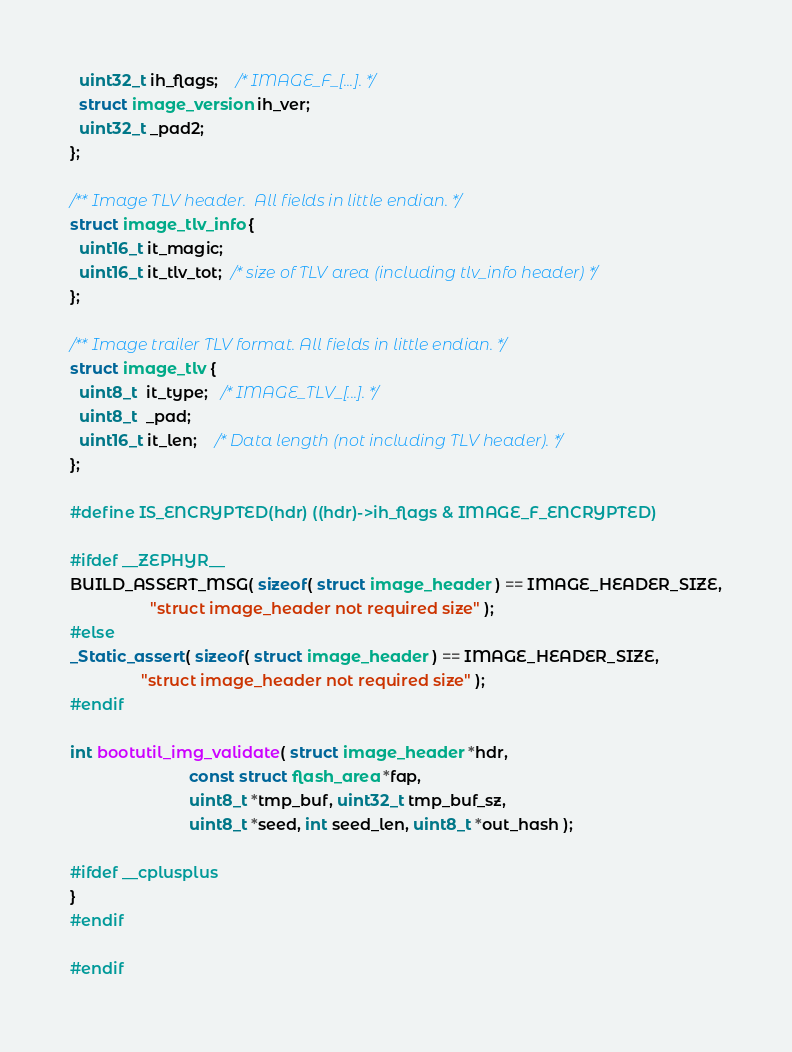Convert code to text. <code><loc_0><loc_0><loc_500><loc_500><_C_>  uint32_t ih_flags;    /* IMAGE_F_[...]. */
  struct image_version ih_ver;
  uint32_t _pad2;
};

/** Image TLV header.  All fields in little endian. */
struct image_tlv_info {
  uint16_t it_magic;
  uint16_t it_tlv_tot;  /* size of TLV area (including tlv_info header) */
};

/** Image trailer TLV format. All fields in little endian. */
struct image_tlv {
  uint8_t  it_type;   /* IMAGE_TLV_[...]. */
  uint8_t  _pad;
  uint16_t it_len;    /* Data length (not including TLV header). */
};

#define IS_ENCRYPTED(hdr) ((hdr)->ih_flags & IMAGE_F_ENCRYPTED)

#ifdef __ZEPHYR__
BUILD_ASSERT_MSG( sizeof( struct image_header ) == IMAGE_HEADER_SIZE,
                  "struct image_header not required size" );
#else
_Static_assert( sizeof( struct image_header ) == IMAGE_HEADER_SIZE,
                "struct image_header not required size" );
#endif

int bootutil_img_validate( struct image_header *hdr,
                           const struct flash_area *fap,
                           uint8_t *tmp_buf, uint32_t tmp_buf_sz,
                           uint8_t *seed, int seed_len, uint8_t *out_hash );

#ifdef __cplusplus
}
#endif

#endif
</code> 